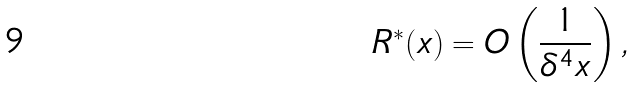<formula> <loc_0><loc_0><loc_500><loc_500>R ^ { * } ( x ) = O \left ( \frac { 1 } { \delta ^ { 4 } x } \right ) ,</formula> 